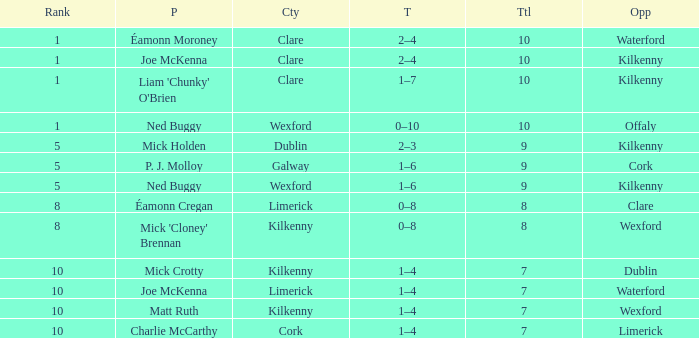Which County has a Rank larger than 8, and a Player of joe mckenna? Limerick. 